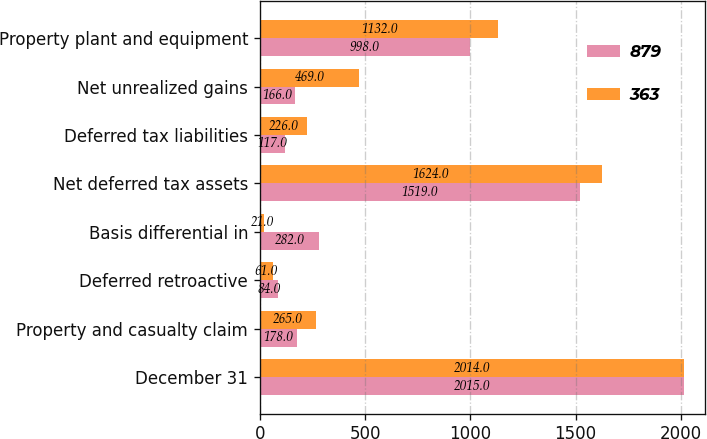<chart> <loc_0><loc_0><loc_500><loc_500><stacked_bar_chart><ecel><fcel>December 31<fcel>Property and casualty claim<fcel>Deferred retroactive<fcel>Basis differential in<fcel>Net deferred tax assets<fcel>Deferred tax liabilities<fcel>Net unrealized gains<fcel>Property plant and equipment<nl><fcel>879<fcel>2015<fcel>178<fcel>84<fcel>282<fcel>1519<fcel>117<fcel>166<fcel>998<nl><fcel>363<fcel>2014<fcel>265<fcel>61<fcel>21<fcel>1624<fcel>226<fcel>469<fcel>1132<nl></chart> 